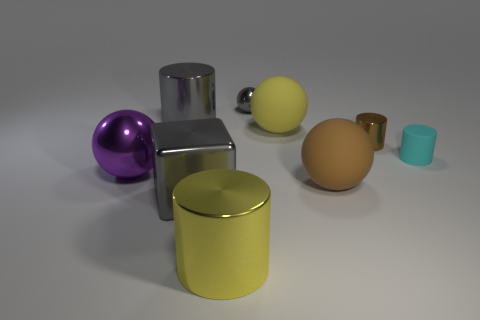What number of other objects are there of the same color as the large cube?
Your response must be concise. 2. Are there any other things that have the same shape as the brown matte thing?
Give a very brief answer. Yes. Are any gray objects visible?
Your answer should be very brief. Yes. There is a cyan object; is its shape the same as the gray metal object that is in front of the brown rubber sphere?
Provide a short and direct response. No. There is a large cylinder behind the big ball behind the small cyan cylinder; what is its material?
Ensure brevity in your answer.  Metal. The block is what color?
Make the answer very short. Gray. There is a big matte object in front of the small cyan matte cylinder; is its color the same as the metallic cylinder that is on the right side of the small gray object?
Give a very brief answer. Yes. What is the size of the yellow rubber thing that is the same shape as the large brown thing?
Give a very brief answer. Large. Is there a cylinder of the same color as the big metal cube?
Ensure brevity in your answer.  Yes. There is a cylinder that is the same color as the tiny sphere; what material is it?
Your answer should be very brief. Metal. 